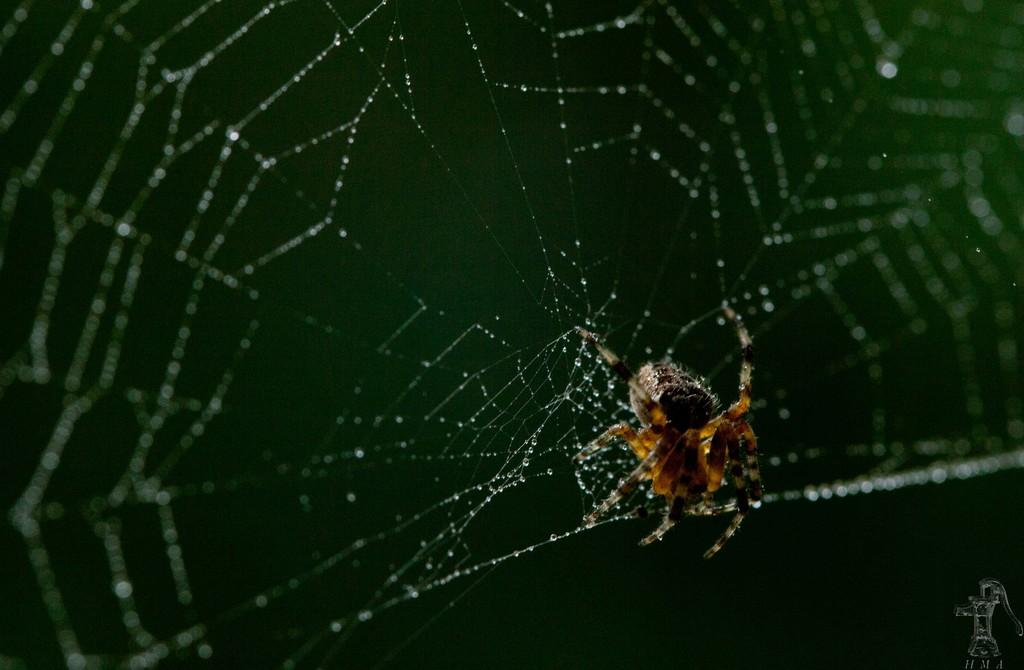What is the main subject of the image? There is an object in the image. Can you describe the object in more detail? There is a spider on a web in the image. What color is the background of the image? The background of the image is green. What word is written on the spider's back in the image? There is no word written on the spider's back in the image; it is a spider on a web. What type of skin is visible on the doll in the image? There is no doll present in the image; it features a spider on a web. 